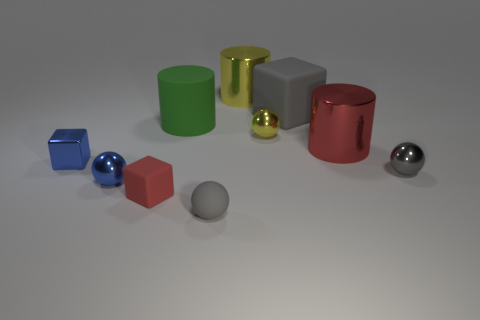How big is the matte block in front of the small blue metal block?
Your answer should be very brief. Small. How many tiny cubes are on the left side of the small gray metal sphere right of the sphere that is to the left of the big green object?
Your answer should be compact. 2. Is the big matte block the same color as the small matte sphere?
Provide a succinct answer. Yes. What number of small objects are in front of the blue sphere and left of the green rubber cylinder?
Keep it short and to the point. 1. The yellow object that is in front of the big yellow metal cylinder has what shape?
Keep it short and to the point. Sphere. Are there fewer large yellow cylinders that are behind the gray cube than small objects in front of the large red cylinder?
Make the answer very short. Yes. Is the gray ball behind the gray matte ball made of the same material as the blue ball that is on the left side of the small yellow ball?
Your response must be concise. Yes. The small red thing has what shape?
Make the answer very short. Cube. Is the number of big green matte cylinders to the left of the gray metal thing greater than the number of tiny blue metallic cubes that are behind the green rubber cylinder?
Your answer should be very brief. Yes. Do the small blue metal thing on the right side of the tiny blue block and the tiny object behind the metal cube have the same shape?
Make the answer very short. Yes. 